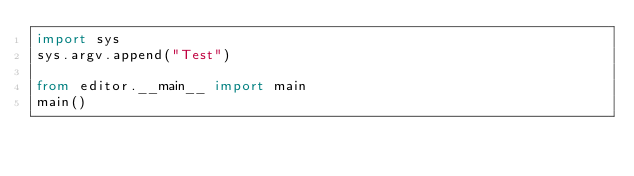Convert code to text. <code><loc_0><loc_0><loc_500><loc_500><_Python_>import sys
sys.argv.append("Test")

from editor.__main__ import main
main()</code> 